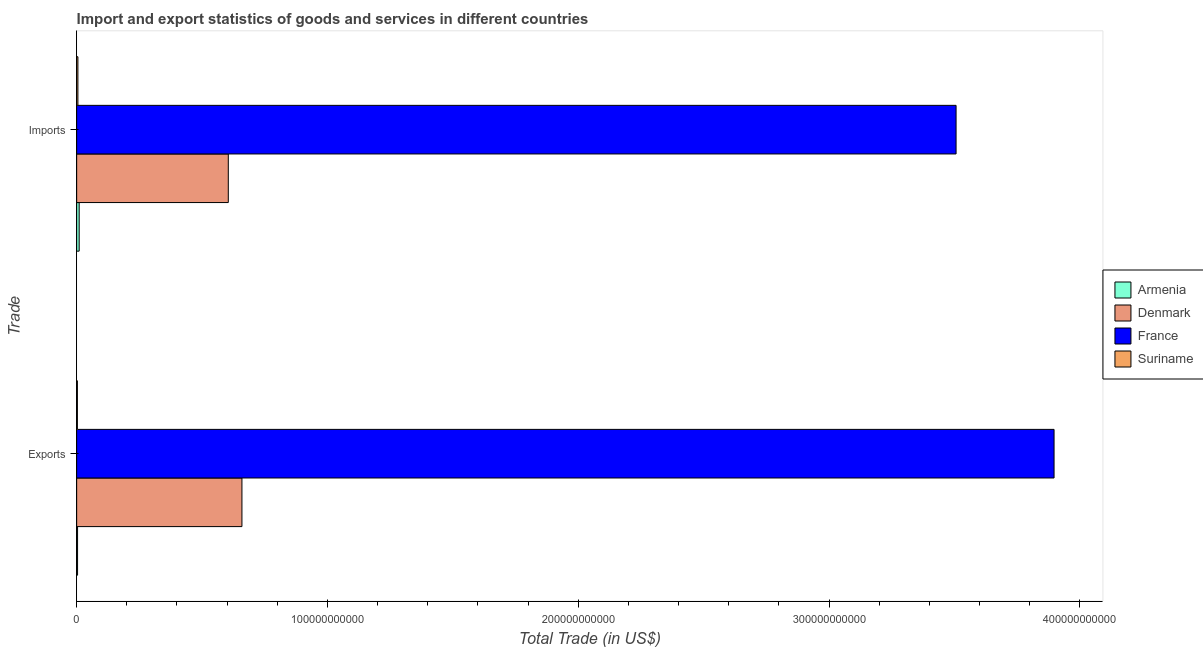How many groups of bars are there?
Provide a succinct answer. 2. Are the number of bars per tick equal to the number of legend labels?
Your answer should be very brief. Yes. Are the number of bars on each tick of the Y-axis equal?
Make the answer very short. Yes. How many bars are there on the 1st tick from the top?
Keep it short and to the point. 4. What is the label of the 2nd group of bars from the top?
Offer a terse response. Exports. What is the imports of goods and services in Suriname?
Your answer should be very brief. 4.96e+08. Across all countries, what is the maximum imports of goods and services?
Provide a succinct answer. 3.51e+11. Across all countries, what is the minimum imports of goods and services?
Ensure brevity in your answer.  4.96e+08. In which country was the imports of goods and services maximum?
Ensure brevity in your answer.  France. In which country was the export of goods and services minimum?
Make the answer very short. Suriname. What is the total export of goods and services in the graph?
Your answer should be compact. 4.56e+11. What is the difference between the export of goods and services in Suriname and that in France?
Give a very brief answer. -3.89e+11. What is the difference between the export of goods and services in France and the imports of goods and services in Denmark?
Your answer should be very brief. 3.29e+11. What is the average imports of goods and services per country?
Your answer should be very brief. 1.03e+11. What is the difference between the export of goods and services and imports of goods and services in France?
Make the answer very short. 3.91e+1. What is the ratio of the imports of goods and services in Denmark to that in France?
Your answer should be compact. 0.17. Is the export of goods and services in Denmark less than that in Armenia?
Ensure brevity in your answer.  No. What does the 4th bar from the bottom in Imports represents?
Offer a terse response. Suriname. How many bars are there?
Keep it short and to the point. 8. What is the difference between two consecutive major ticks on the X-axis?
Ensure brevity in your answer.  1.00e+11. Does the graph contain any zero values?
Offer a very short reply. No. Where does the legend appear in the graph?
Offer a very short reply. Center right. How many legend labels are there?
Your response must be concise. 4. How are the legend labels stacked?
Provide a short and direct response. Vertical. What is the title of the graph?
Make the answer very short. Import and export statistics of goods and services in different countries. What is the label or title of the X-axis?
Your response must be concise. Total Trade (in US$). What is the label or title of the Y-axis?
Offer a very short reply. Trade. What is the Total Trade (in US$) in Armenia in Exports?
Provide a succinct answer. 3.60e+08. What is the Total Trade (in US$) of Denmark in Exports?
Provide a short and direct response. 6.59e+1. What is the Total Trade (in US$) of France in Exports?
Give a very brief answer. 3.90e+11. What is the Total Trade (in US$) of Suriname in Exports?
Provide a succinct answer. 2.94e+08. What is the Total Trade (in US$) of Armenia in Imports?
Your answer should be very brief. 1.00e+09. What is the Total Trade (in US$) in Denmark in Imports?
Ensure brevity in your answer.  6.05e+1. What is the Total Trade (in US$) of France in Imports?
Your response must be concise. 3.51e+11. What is the Total Trade (in US$) in Suriname in Imports?
Offer a very short reply. 4.96e+08. Across all Trade, what is the maximum Total Trade (in US$) of Armenia?
Your response must be concise. 1.00e+09. Across all Trade, what is the maximum Total Trade (in US$) of Denmark?
Make the answer very short. 6.59e+1. Across all Trade, what is the maximum Total Trade (in US$) in France?
Your response must be concise. 3.90e+11. Across all Trade, what is the maximum Total Trade (in US$) of Suriname?
Provide a succinct answer. 4.96e+08. Across all Trade, what is the minimum Total Trade (in US$) of Armenia?
Keep it short and to the point. 3.60e+08. Across all Trade, what is the minimum Total Trade (in US$) of Denmark?
Ensure brevity in your answer.  6.05e+1. Across all Trade, what is the minimum Total Trade (in US$) in France?
Provide a succinct answer. 3.51e+11. Across all Trade, what is the minimum Total Trade (in US$) of Suriname?
Provide a succinct answer. 2.94e+08. What is the total Total Trade (in US$) in Armenia in the graph?
Ensure brevity in your answer.  1.36e+09. What is the total Total Trade (in US$) of Denmark in the graph?
Ensure brevity in your answer.  1.26e+11. What is the total Total Trade (in US$) of France in the graph?
Offer a terse response. 7.40e+11. What is the total Total Trade (in US$) in Suriname in the graph?
Offer a terse response. 7.90e+08. What is the difference between the Total Trade (in US$) in Armenia in Exports and that in Imports?
Provide a short and direct response. -6.41e+08. What is the difference between the Total Trade (in US$) in Denmark in Exports and that in Imports?
Make the answer very short. 5.44e+09. What is the difference between the Total Trade (in US$) in France in Exports and that in Imports?
Your answer should be compact. 3.91e+1. What is the difference between the Total Trade (in US$) of Suriname in Exports and that in Imports?
Keep it short and to the point. -2.02e+08. What is the difference between the Total Trade (in US$) of Armenia in Exports and the Total Trade (in US$) of Denmark in Imports?
Ensure brevity in your answer.  -6.01e+1. What is the difference between the Total Trade (in US$) of Armenia in Exports and the Total Trade (in US$) of France in Imports?
Your answer should be very brief. -3.50e+11. What is the difference between the Total Trade (in US$) of Armenia in Exports and the Total Trade (in US$) of Suriname in Imports?
Provide a short and direct response. -1.36e+08. What is the difference between the Total Trade (in US$) in Denmark in Exports and the Total Trade (in US$) in France in Imports?
Offer a very short reply. -2.85e+11. What is the difference between the Total Trade (in US$) in Denmark in Exports and the Total Trade (in US$) in Suriname in Imports?
Provide a short and direct response. 6.54e+1. What is the difference between the Total Trade (in US$) in France in Exports and the Total Trade (in US$) in Suriname in Imports?
Your answer should be compact. 3.89e+11. What is the average Total Trade (in US$) of Armenia per Trade?
Your answer should be very brief. 6.80e+08. What is the average Total Trade (in US$) in Denmark per Trade?
Offer a terse response. 6.32e+1. What is the average Total Trade (in US$) of France per Trade?
Your response must be concise. 3.70e+11. What is the average Total Trade (in US$) of Suriname per Trade?
Offer a terse response. 3.95e+08. What is the difference between the Total Trade (in US$) in Armenia and Total Trade (in US$) in Denmark in Exports?
Give a very brief answer. -6.55e+1. What is the difference between the Total Trade (in US$) in Armenia and Total Trade (in US$) in France in Exports?
Make the answer very short. -3.89e+11. What is the difference between the Total Trade (in US$) of Armenia and Total Trade (in US$) of Suriname in Exports?
Your answer should be compact. 6.59e+07. What is the difference between the Total Trade (in US$) of Denmark and Total Trade (in US$) of France in Exports?
Give a very brief answer. -3.24e+11. What is the difference between the Total Trade (in US$) of Denmark and Total Trade (in US$) of Suriname in Exports?
Offer a very short reply. 6.56e+1. What is the difference between the Total Trade (in US$) of France and Total Trade (in US$) of Suriname in Exports?
Ensure brevity in your answer.  3.89e+11. What is the difference between the Total Trade (in US$) of Armenia and Total Trade (in US$) of Denmark in Imports?
Provide a succinct answer. -5.95e+1. What is the difference between the Total Trade (in US$) of Armenia and Total Trade (in US$) of France in Imports?
Give a very brief answer. -3.50e+11. What is the difference between the Total Trade (in US$) of Armenia and Total Trade (in US$) of Suriname in Imports?
Ensure brevity in your answer.  5.05e+08. What is the difference between the Total Trade (in US$) of Denmark and Total Trade (in US$) of France in Imports?
Your response must be concise. -2.90e+11. What is the difference between the Total Trade (in US$) of Denmark and Total Trade (in US$) of Suriname in Imports?
Offer a terse response. 6.00e+1. What is the difference between the Total Trade (in US$) of France and Total Trade (in US$) of Suriname in Imports?
Provide a succinct answer. 3.50e+11. What is the ratio of the Total Trade (in US$) in Armenia in Exports to that in Imports?
Offer a terse response. 0.36. What is the ratio of the Total Trade (in US$) in Denmark in Exports to that in Imports?
Keep it short and to the point. 1.09. What is the ratio of the Total Trade (in US$) in France in Exports to that in Imports?
Keep it short and to the point. 1.11. What is the ratio of the Total Trade (in US$) of Suriname in Exports to that in Imports?
Make the answer very short. 0.59. What is the difference between the highest and the second highest Total Trade (in US$) of Armenia?
Make the answer very short. 6.41e+08. What is the difference between the highest and the second highest Total Trade (in US$) of Denmark?
Give a very brief answer. 5.44e+09. What is the difference between the highest and the second highest Total Trade (in US$) in France?
Ensure brevity in your answer.  3.91e+1. What is the difference between the highest and the second highest Total Trade (in US$) of Suriname?
Provide a succinct answer. 2.02e+08. What is the difference between the highest and the lowest Total Trade (in US$) of Armenia?
Provide a short and direct response. 6.41e+08. What is the difference between the highest and the lowest Total Trade (in US$) in Denmark?
Make the answer very short. 5.44e+09. What is the difference between the highest and the lowest Total Trade (in US$) in France?
Your answer should be compact. 3.91e+1. What is the difference between the highest and the lowest Total Trade (in US$) in Suriname?
Your response must be concise. 2.02e+08. 